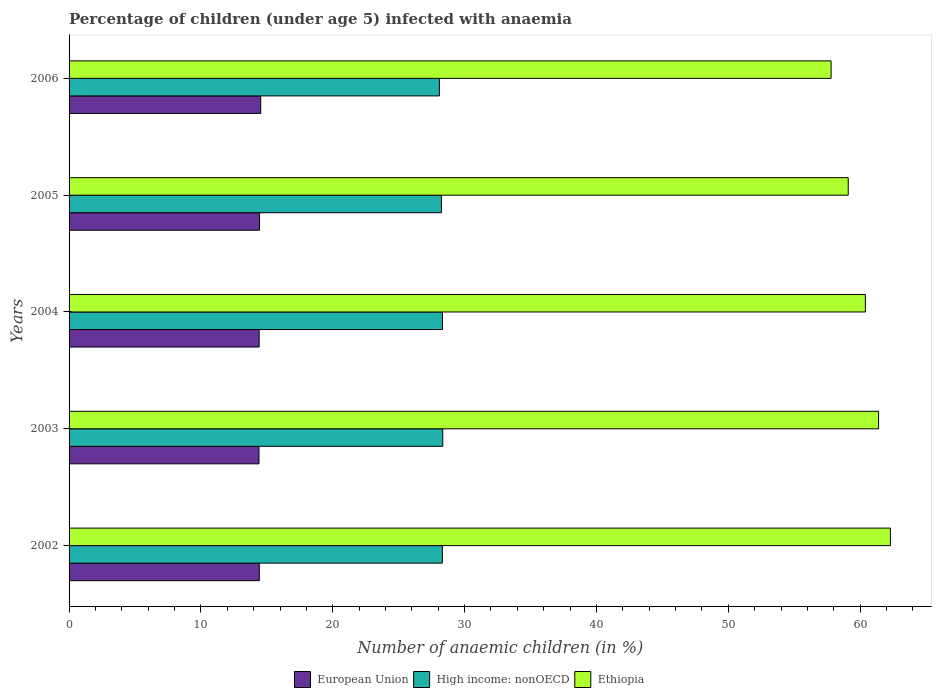How many groups of bars are there?
Keep it short and to the point. 5. Are the number of bars on each tick of the Y-axis equal?
Make the answer very short. Yes. How many bars are there on the 3rd tick from the top?
Your answer should be compact. 3. In how many cases, is the number of bars for a given year not equal to the number of legend labels?
Provide a succinct answer. 0. What is the percentage of children infected with anaemia in in European Union in 2002?
Your response must be concise. 14.43. Across all years, what is the maximum percentage of children infected with anaemia in in High income: nonOECD?
Your answer should be compact. 28.34. Across all years, what is the minimum percentage of children infected with anaemia in in High income: nonOECD?
Make the answer very short. 28.09. In which year was the percentage of children infected with anaemia in in European Union minimum?
Your answer should be compact. 2003. What is the total percentage of children infected with anaemia in in European Union in the graph?
Give a very brief answer. 72.24. What is the difference between the percentage of children infected with anaemia in in Ethiopia in 2005 and the percentage of children infected with anaemia in in European Union in 2002?
Your answer should be very brief. 44.67. What is the average percentage of children infected with anaemia in in Ethiopia per year?
Make the answer very short. 60.2. In the year 2004, what is the difference between the percentage of children infected with anaemia in in Ethiopia and percentage of children infected with anaemia in in High income: nonOECD?
Your answer should be compact. 32.08. In how many years, is the percentage of children infected with anaemia in in European Union greater than 38 %?
Provide a succinct answer. 0. What is the ratio of the percentage of children infected with anaemia in in Ethiopia in 2003 to that in 2004?
Ensure brevity in your answer.  1.02. What is the difference between the highest and the second highest percentage of children infected with anaemia in in European Union?
Offer a terse response. 0.09. In how many years, is the percentage of children infected with anaemia in in Ethiopia greater than the average percentage of children infected with anaemia in in Ethiopia taken over all years?
Provide a succinct answer. 3. Is the sum of the percentage of children infected with anaemia in in High income: nonOECD in 2002 and 2004 greater than the maximum percentage of children infected with anaemia in in Ethiopia across all years?
Provide a short and direct response. No. What does the 2nd bar from the bottom in 2006 represents?
Offer a very short reply. High income: nonOECD. How many bars are there?
Offer a very short reply. 15. Are all the bars in the graph horizontal?
Ensure brevity in your answer.  Yes. What is the difference between two consecutive major ticks on the X-axis?
Provide a short and direct response. 10. Does the graph contain grids?
Provide a short and direct response. No. How are the legend labels stacked?
Keep it short and to the point. Horizontal. What is the title of the graph?
Offer a terse response. Percentage of children (under age 5) infected with anaemia. What is the label or title of the X-axis?
Provide a short and direct response. Number of anaemic children (in %). What is the Number of anaemic children (in %) in European Union in 2002?
Ensure brevity in your answer.  14.43. What is the Number of anaemic children (in %) in High income: nonOECD in 2002?
Ensure brevity in your answer.  28.31. What is the Number of anaemic children (in %) of Ethiopia in 2002?
Keep it short and to the point. 62.3. What is the Number of anaemic children (in %) of European Union in 2003?
Make the answer very short. 14.41. What is the Number of anaemic children (in %) of High income: nonOECD in 2003?
Provide a succinct answer. 28.34. What is the Number of anaemic children (in %) of Ethiopia in 2003?
Offer a terse response. 61.4. What is the Number of anaemic children (in %) in European Union in 2004?
Ensure brevity in your answer.  14.42. What is the Number of anaemic children (in %) of High income: nonOECD in 2004?
Provide a succinct answer. 28.32. What is the Number of anaemic children (in %) of Ethiopia in 2004?
Your answer should be very brief. 60.4. What is the Number of anaemic children (in %) of European Union in 2005?
Make the answer very short. 14.45. What is the Number of anaemic children (in %) of High income: nonOECD in 2005?
Make the answer very short. 28.24. What is the Number of anaemic children (in %) in Ethiopia in 2005?
Keep it short and to the point. 59.1. What is the Number of anaemic children (in %) in European Union in 2006?
Ensure brevity in your answer.  14.54. What is the Number of anaemic children (in %) of High income: nonOECD in 2006?
Give a very brief answer. 28.09. What is the Number of anaemic children (in %) in Ethiopia in 2006?
Your response must be concise. 57.8. Across all years, what is the maximum Number of anaemic children (in %) in European Union?
Provide a succinct answer. 14.54. Across all years, what is the maximum Number of anaemic children (in %) of High income: nonOECD?
Your answer should be very brief. 28.34. Across all years, what is the maximum Number of anaemic children (in %) in Ethiopia?
Give a very brief answer. 62.3. Across all years, what is the minimum Number of anaemic children (in %) in European Union?
Ensure brevity in your answer.  14.41. Across all years, what is the minimum Number of anaemic children (in %) of High income: nonOECD?
Provide a succinct answer. 28.09. Across all years, what is the minimum Number of anaemic children (in %) in Ethiopia?
Ensure brevity in your answer.  57.8. What is the total Number of anaemic children (in %) in European Union in the graph?
Provide a succinct answer. 72.24. What is the total Number of anaemic children (in %) in High income: nonOECD in the graph?
Keep it short and to the point. 141.31. What is the total Number of anaemic children (in %) of Ethiopia in the graph?
Keep it short and to the point. 301. What is the difference between the Number of anaemic children (in %) of European Union in 2002 and that in 2003?
Your response must be concise. 0.03. What is the difference between the Number of anaemic children (in %) in High income: nonOECD in 2002 and that in 2003?
Offer a terse response. -0.03. What is the difference between the Number of anaemic children (in %) of Ethiopia in 2002 and that in 2003?
Your answer should be very brief. 0.9. What is the difference between the Number of anaemic children (in %) in European Union in 2002 and that in 2004?
Provide a short and direct response. 0.01. What is the difference between the Number of anaemic children (in %) in High income: nonOECD in 2002 and that in 2004?
Provide a short and direct response. -0.01. What is the difference between the Number of anaemic children (in %) in Ethiopia in 2002 and that in 2004?
Provide a succinct answer. 1.9. What is the difference between the Number of anaemic children (in %) in European Union in 2002 and that in 2005?
Your response must be concise. -0.02. What is the difference between the Number of anaemic children (in %) of High income: nonOECD in 2002 and that in 2005?
Your response must be concise. 0.07. What is the difference between the Number of anaemic children (in %) of Ethiopia in 2002 and that in 2005?
Your response must be concise. 3.2. What is the difference between the Number of anaemic children (in %) in European Union in 2002 and that in 2006?
Provide a short and direct response. -0.11. What is the difference between the Number of anaemic children (in %) of High income: nonOECD in 2002 and that in 2006?
Provide a short and direct response. 0.23. What is the difference between the Number of anaemic children (in %) of European Union in 2003 and that in 2004?
Your answer should be compact. -0.01. What is the difference between the Number of anaemic children (in %) of High income: nonOECD in 2003 and that in 2004?
Your answer should be very brief. 0.02. What is the difference between the Number of anaemic children (in %) in European Union in 2003 and that in 2005?
Provide a succinct answer. -0.04. What is the difference between the Number of anaemic children (in %) of High income: nonOECD in 2003 and that in 2005?
Provide a succinct answer. 0.1. What is the difference between the Number of anaemic children (in %) of European Union in 2003 and that in 2006?
Offer a very short reply. -0.13. What is the difference between the Number of anaemic children (in %) in High income: nonOECD in 2003 and that in 2006?
Offer a very short reply. 0.26. What is the difference between the Number of anaemic children (in %) in Ethiopia in 2003 and that in 2006?
Ensure brevity in your answer.  3.6. What is the difference between the Number of anaemic children (in %) of European Union in 2004 and that in 2005?
Keep it short and to the point. -0.03. What is the difference between the Number of anaemic children (in %) of High income: nonOECD in 2004 and that in 2005?
Provide a succinct answer. 0.08. What is the difference between the Number of anaemic children (in %) of Ethiopia in 2004 and that in 2005?
Your answer should be compact. 1.3. What is the difference between the Number of anaemic children (in %) in European Union in 2004 and that in 2006?
Provide a short and direct response. -0.12. What is the difference between the Number of anaemic children (in %) of High income: nonOECD in 2004 and that in 2006?
Your answer should be very brief. 0.23. What is the difference between the Number of anaemic children (in %) of Ethiopia in 2004 and that in 2006?
Make the answer very short. 2.6. What is the difference between the Number of anaemic children (in %) in European Union in 2005 and that in 2006?
Your response must be concise. -0.09. What is the difference between the Number of anaemic children (in %) of High income: nonOECD in 2005 and that in 2006?
Give a very brief answer. 0.15. What is the difference between the Number of anaemic children (in %) of European Union in 2002 and the Number of anaemic children (in %) of High income: nonOECD in 2003?
Give a very brief answer. -13.91. What is the difference between the Number of anaemic children (in %) in European Union in 2002 and the Number of anaemic children (in %) in Ethiopia in 2003?
Give a very brief answer. -46.97. What is the difference between the Number of anaemic children (in %) in High income: nonOECD in 2002 and the Number of anaemic children (in %) in Ethiopia in 2003?
Offer a very short reply. -33.09. What is the difference between the Number of anaemic children (in %) of European Union in 2002 and the Number of anaemic children (in %) of High income: nonOECD in 2004?
Offer a terse response. -13.89. What is the difference between the Number of anaemic children (in %) in European Union in 2002 and the Number of anaemic children (in %) in Ethiopia in 2004?
Give a very brief answer. -45.97. What is the difference between the Number of anaemic children (in %) in High income: nonOECD in 2002 and the Number of anaemic children (in %) in Ethiopia in 2004?
Ensure brevity in your answer.  -32.09. What is the difference between the Number of anaemic children (in %) in European Union in 2002 and the Number of anaemic children (in %) in High income: nonOECD in 2005?
Give a very brief answer. -13.81. What is the difference between the Number of anaemic children (in %) in European Union in 2002 and the Number of anaemic children (in %) in Ethiopia in 2005?
Offer a terse response. -44.67. What is the difference between the Number of anaemic children (in %) of High income: nonOECD in 2002 and the Number of anaemic children (in %) of Ethiopia in 2005?
Offer a very short reply. -30.79. What is the difference between the Number of anaemic children (in %) of European Union in 2002 and the Number of anaemic children (in %) of High income: nonOECD in 2006?
Provide a short and direct response. -13.66. What is the difference between the Number of anaemic children (in %) of European Union in 2002 and the Number of anaemic children (in %) of Ethiopia in 2006?
Ensure brevity in your answer.  -43.37. What is the difference between the Number of anaemic children (in %) in High income: nonOECD in 2002 and the Number of anaemic children (in %) in Ethiopia in 2006?
Provide a succinct answer. -29.49. What is the difference between the Number of anaemic children (in %) in European Union in 2003 and the Number of anaemic children (in %) in High income: nonOECD in 2004?
Provide a succinct answer. -13.92. What is the difference between the Number of anaemic children (in %) of European Union in 2003 and the Number of anaemic children (in %) of Ethiopia in 2004?
Make the answer very short. -45.99. What is the difference between the Number of anaemic children (in %) of High income: nonOECD in 2003 and the Number of anaemic children (in %) of Ethiopia in 2004?
Offer a very short reply. -32.06. What is the difference between the Number of anaemic children (in %) in European Union in 2003 and the Number of anaemic children (in %) in High income: nonOECD in 2005?
Keep it short and to the point. -13.84. What is the difference between the Number of anaemic children (in %) in European Union in 2003 and the Number of anaemic children (in %) in Ethiopia in 2005?
Your answer should be compact. -44.7. What is the difference between the Number of anaemic children (in %) of High income: nonOECD in 2003 and the Number of anaemic children (in %) of Ethiopia in 2005?
Ensure brevity in your answer.  -30.76. What is the difference between the Number of anaemic children (in %) of European Union in 2003 and the Number of anaemic children (in %) of High income: nonOECD in 2006?
Give a very brief answer. -13.68. What is the difference between the Number of anaemic children (in %) in European Union in 2003 and the Number of anaemic children (in %) in Ethiopia in 2006?
Offer a terse response. -43.4. What is the difference between the Number of anaemic children (in %) in High income: nonOECD in 2003 and the Number of anaemic children (in %) in Ethiopia in 2006?
Offer a terse response. -29.46. What is the difference between the Number of anaemic children (in %) of European Union in 2004 and the Number of anaemic children (in %) of High income: nonOECD in 2005?
Make the answer very short. -13.82. What is the difference between the Number of anaemic children (in %) of European Union in 2004 and the Number of anaemic children (in %) of Ethiopia in 2005?
Offer a very short reply. -44.68. What is the difference between the Number of anaemic children (in %) of High income: nonOECD in 2004 and the Number of anaemic children (in %) of Ethiopia in 2005?
Provide a succinct answer. -30.78. What is the difference between the Number of anaemic children (in %) of European Union in 2004 and the Number of anaemic children (in %) of High income: nonOECD in 2006?
Keep it short and to the point. -13.67. What is the difference between the Number of anaemic children (in %) of European Union in 2004 and the Number of anaemic children (in %) of Ethiopia in 2006?
Make the answer very short. -43.38. What is the difference between the Number of anaemic children (in %) in High income: nonOECD in 2004 and the Number of anaemic children (in %) in Ethiopia in 2006?
Your response must be concise. -29.48. What is the difference between the Number of anaemic children (in %) in European Union in 2005 and the Number of anaemic children (in %) in High income: nonOECD in 2006?
Your response must be concise. -13.64. What is the difference between the Number of anaemic children (in %) in European Union in 2005 and the Number of anaemic children (in %) in Ethiopia in 2006?
Provide a succinct answer. -43.35. What is the difference between the Number of anaemic children (in %) in High income: nonOECD in 2005 and the Number of anaemic children (in %) in Ethiopia in 2006?
Provide a succinct answer. -29.56. What is the average Number of anaemic children (in %) of European Union per year?
Your answer should be compact. 14.45. What is the average Number of anaemic children (in %) of High income: nonOECD per year?
Offer a terse response. 28.26. What is the average Number of anaemic children (in %) in Ethiopia per year?
Keep it short and to the point. 60.2. In the year 2002, what is the difference between the Number of anaemic children (in %) of European Union and Number of anaemic children (in %) of High income: nonOECD?
Make the answer very short. -13.88. In the year 2002, what is the difference between the Number of anaemic children (in %) of European Union and Number of anaemic children (in %) of Ethiopia?
Offer a very short reply. -47.87. In the year 2002, what is the difference between the Number of anaemic children (in %) of High income: nonOECD and Number of anaemic children (in %) of Ethiopia?
Offer a terse response. -33.99. In the year 2003, what is the difference between the Number of anaemic children (in %) in European Union and Number of anaemic children (in %) in High income: nonOECD?
Provide a short and direct response. -13.94. In the year 2003, what is the difference between the Number of anaemic children (in %) in European Union and Number of anaemic children (in %) in Ethiopia?
Your answer should be very brief. -46.99. In the year 2003, what is the difference between the Number of anaemic children (in %) in High income: nonOECD and Number of anaemic children (in %) in Ethiopia?
Your answer should be very brief. -33.06. In the year 2004, what is the difference between the Number of anaemic children (in %) of European Union and Number of anaemic children (in %) of High income: nonOECD?
Your answer should be compact. -13.9. In the year 2004, what is the difference between the Number of anaemic children (in %) in European Union and Number of anaemic children (in %) in Ethiopia?
Offer a terse response. -45.98. In the year 2004, what is the difference between the Number of anaemic children (in %) in High income: nonOECD and Number of anaemic children (in %) in Ethiopia?
Provide a succinct answer. -32.08. In the year 2005, what is the difference between the Number of anaemic children (in %) in European Union and Number of anaemic children (in %) in High income: nonOECD?
Your answer should be compact. -13.79. In the year 2005, what is the difference between the Number of anaemic children (in %) in European Union and Number of anaemic children (in %) in Ethiopia?
Give a very brief answer. -44.65. In the year 2005, what is the difference between the Number of anaemic children (in %) in High income: nonOECD and Number of anaemic children (in %) in Ethiopia?
Your answer should be very brief. -30.86. In the year 2006, what is the difference between the Number of anaemic children (in %) of European Union and Number of anaemic children (in %) of High income: nonOECD?
Give a very brief answer. -13.55. In the year 2006, what is the difference between the Number of anaemic children (in %) of European Union and Number of anaemic children (in %) of Ethiopia?
Make the answer very short. -43.26. In the year 2006, what is the difference between the Number of anaemic children (in %) of High income: nonOECD and Number of anaemic children (in %) of Ethiopia?
Make the answer very short. -29.71. What is the ratio of the Number of anaemic children (in %) of European Union in 2002 to that in 2003?
Offer a very short reply. 1. What is the ratio of the Number of anaemic children (in %) of Ethiopia in 2002 to that in 2003?
Keep it short and to the point. 1.01. What is the ratio of the Number of anaemic children (in %) of European Union in 2002 to that in 2004?
Your answer should be compact. 1. What is the ratio of the Number of anaemic children (in %) of Ethiopia in 2002 to that in 2004?
Make the answer very short. 1.03. What is the ratio of the Number of anaemic children (in %) of European Union in 2002 to that in 2005?
Your answer should be compact. 1. What is the ratio of the Number of anaemic children (in %) in High income: nonOECD in 2002 to that in 2005?
Offer a terse response. 1. What is the ratio of the Number of anaemic children (in %) in Ethiopia in 2002 to that in 2005?
Make the answer very short. 1.05. What is the ratio of the Number of anaemic children (in %) in Ethiopia in 2002 to that in 2006?
Give a very brief answer. 1.08. What is the ratio of the Number of anaemic children (in %) of Ethiopia in 2003 to that in 2004?
Make the answer very short. 1.02. What is the ratio of the Number of anaemic children (in %) of European Union in 2003 to that in 2005?
Offer a terse response. 1. What is the ratio of the Number of anaemic children (in %) of High income: nonOECD in 2003 to that in 2005?
Your answer should be compact. 1. What is the ratio of the Number of anaemic children (in %) of Ethiopia in 2003 to that in 2005?
Make the answer very short. 1.04. What is the ratio of the Number of anaemic children (in %) of High income: nonOECD in 2003 to that in 2006?
Your response must be concise. 1.01. What is the ratio of the Number of anaemic children (in %) in Ethiopia in 2003 to that in 2006?
Provide a short and direct response. 1.06. What is the ratio of the Number of anaemic children (in %) in High income: nonOECD in 2004 to that in 2005?
Your answer should be very brief. 1. What is the ratio of the Number of anaemic children (in %) of Ethiopia in 2004 to that in 2005?
Offer a very short reply. 1.02. What is the ratio of the Number of anaemic children (in %) in European Union in 2004 to that in 2006?
Your answer should be very brief. 0.99. What is the ratio of the Number of anaemic children (in %) in High income: nonOECD in 2004 to that in 2006?
Offer a terse response. 1.01. What is the ratio of the Number of anaemic children (in %) in Ethiopia in 2004 to that in 2006?
Your answer should be very brief. 1.04. What is the ratio of the Number of anaemic children (in %) in European Union in 2005 to that in 2006?
Give a very brief answer. 0.99. What is the ratio of the Number of anaemic children (in %) of Ethiopia in 2005 to that in 2006?
Provide a succinct answer. 1.02. What is the difference between the highest and the second highest Number of anaemic children (in %) in European Union?
Make the answer very short. 0.09. What is the difference between the highest and the second highest Number of anaemic children (in %) of High income: nonOECD?
Your response must be concise. 0.02. What is the difference between the highest and the lowest Number of anaemic children (in %) in European Union?
Keep it short and to the point. 0.13. What is the difference between the highest and the lowest Number of anaemic children (in %) in High income: nonOECD?
Offer a very short reply. 0.26. What is the difference between the highest and the lowest Number of anaemic children (in %) of Ethiopia?
Offer a terse response. 4.5. 